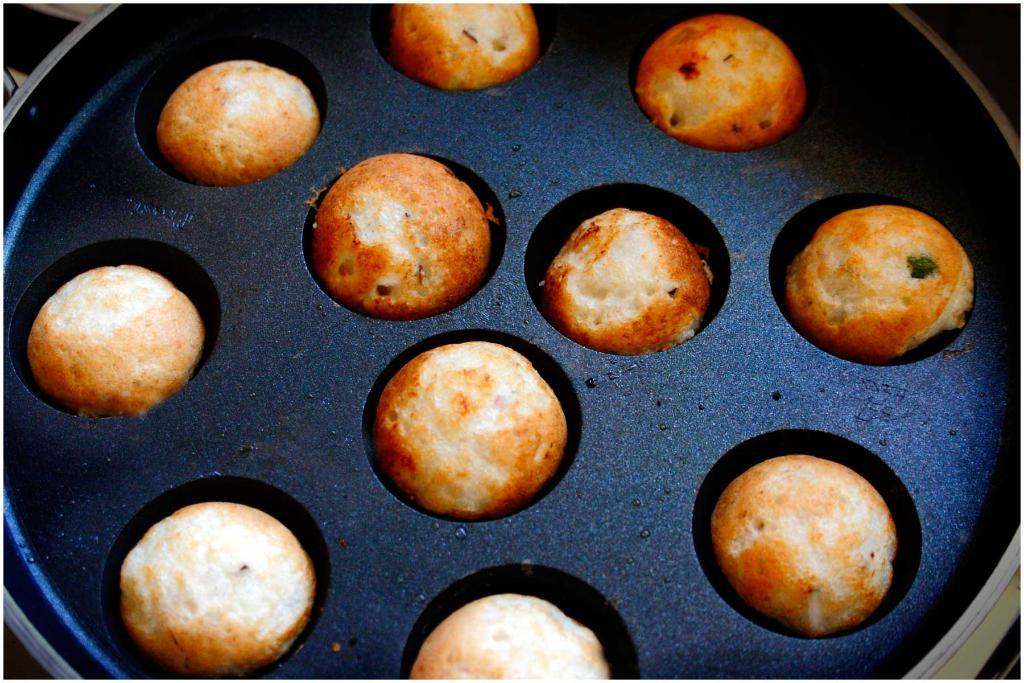What is present in the image that is used for cooking or heating food? There is a pan in the image that is used for cooking or heating food. What is inside the pan in the image? The pan contains food. Where is the cactus located in the image? There is no cactus present in the image. What type of town is depicted in the image? There is no town depicted in the image; it only features a pan with food. 